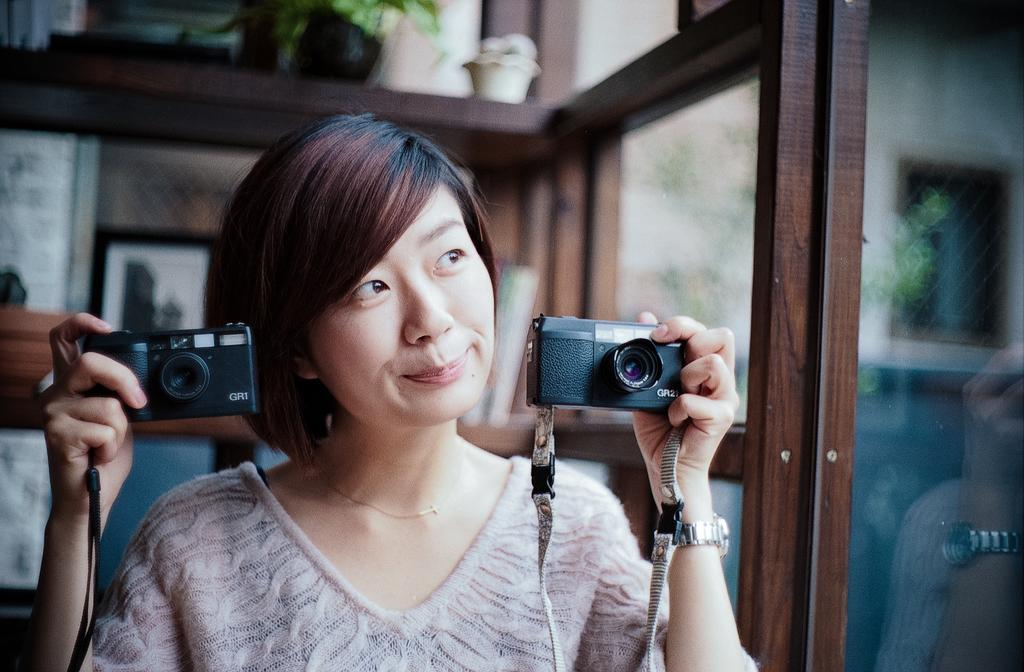Who is the main subject in the image? There is a woman in the center of the image. What is the woman holding in her hands? The woman is holding a camera in both hands. How does the woman appear in the image? The woman has a pretty smile on her face. What objects can be seen in the background of the image? There is a glass and a clay pot in the background of the image. How many toes can be seen on the woman's feet in the image? There is no visible indication of the woman's feet in the image, so the number of toes cannot be determined. 